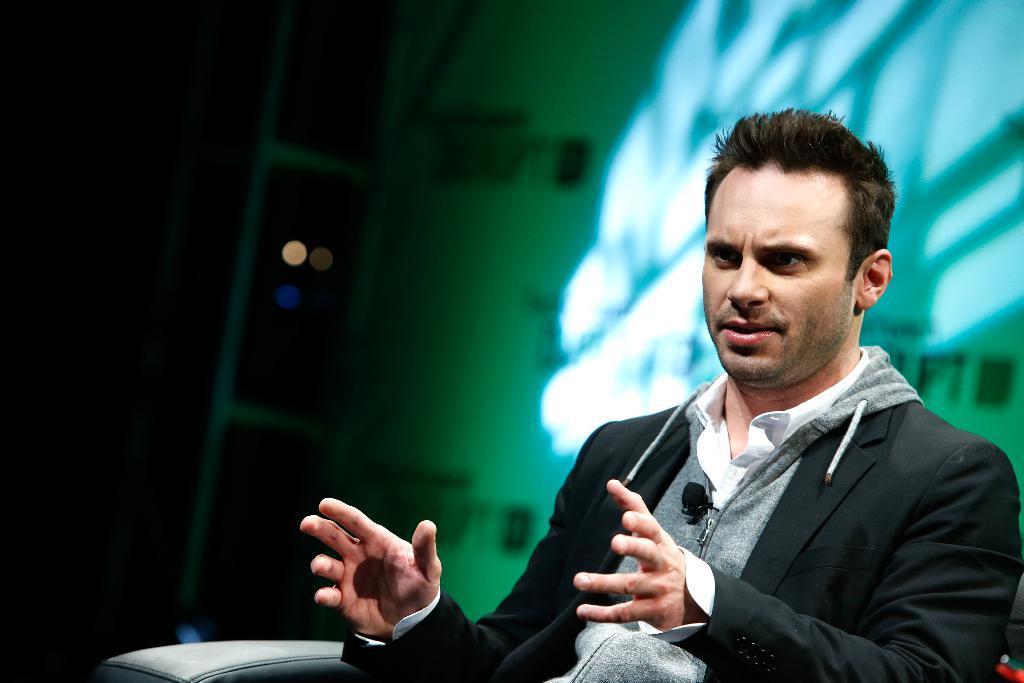Can you describe this image briefly? In this image there is a person sitting on the chair. Behind him there is a banner having some text. 